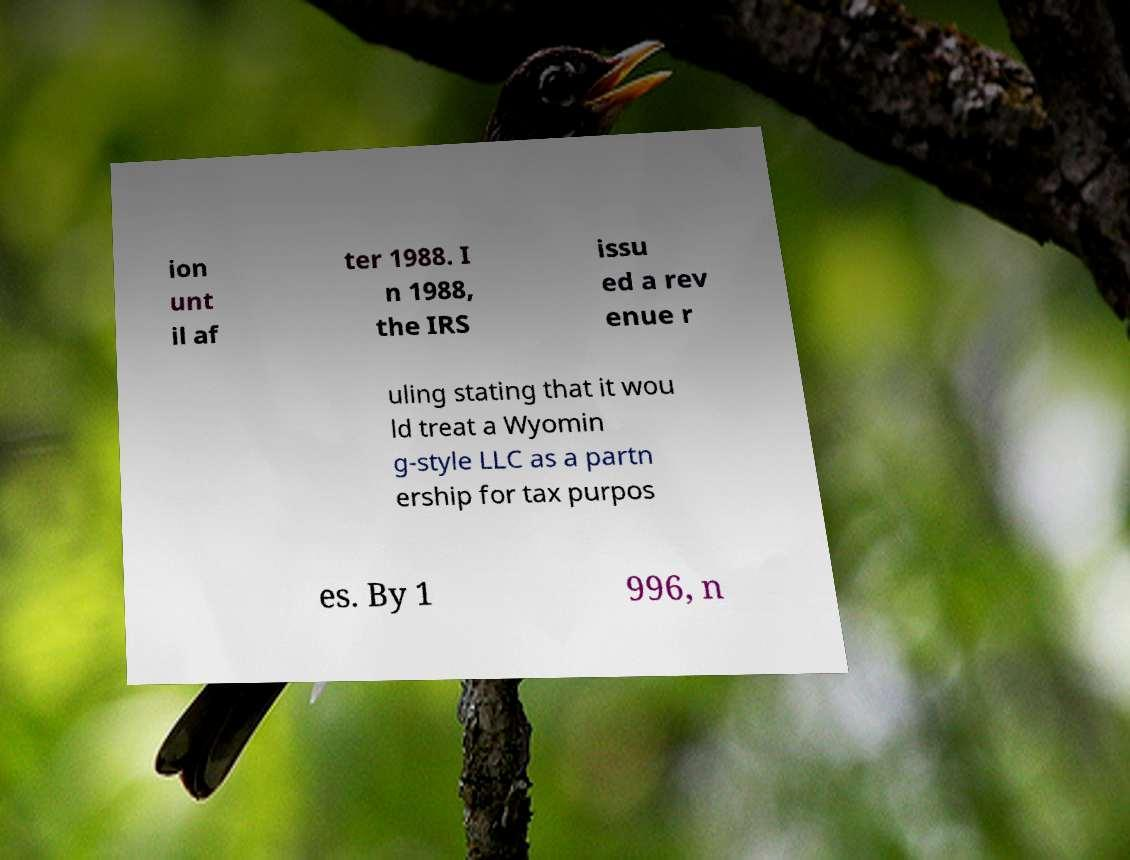Can you accurately transcribe the text from the provided image for me? ion unt il af ter 1988. I n 1988, the IRS issu ed a rev enue r uling stating that it wou ld treat a Wyomin g-style LLC as a partn ership for tax purpos es. By 1 996, n 